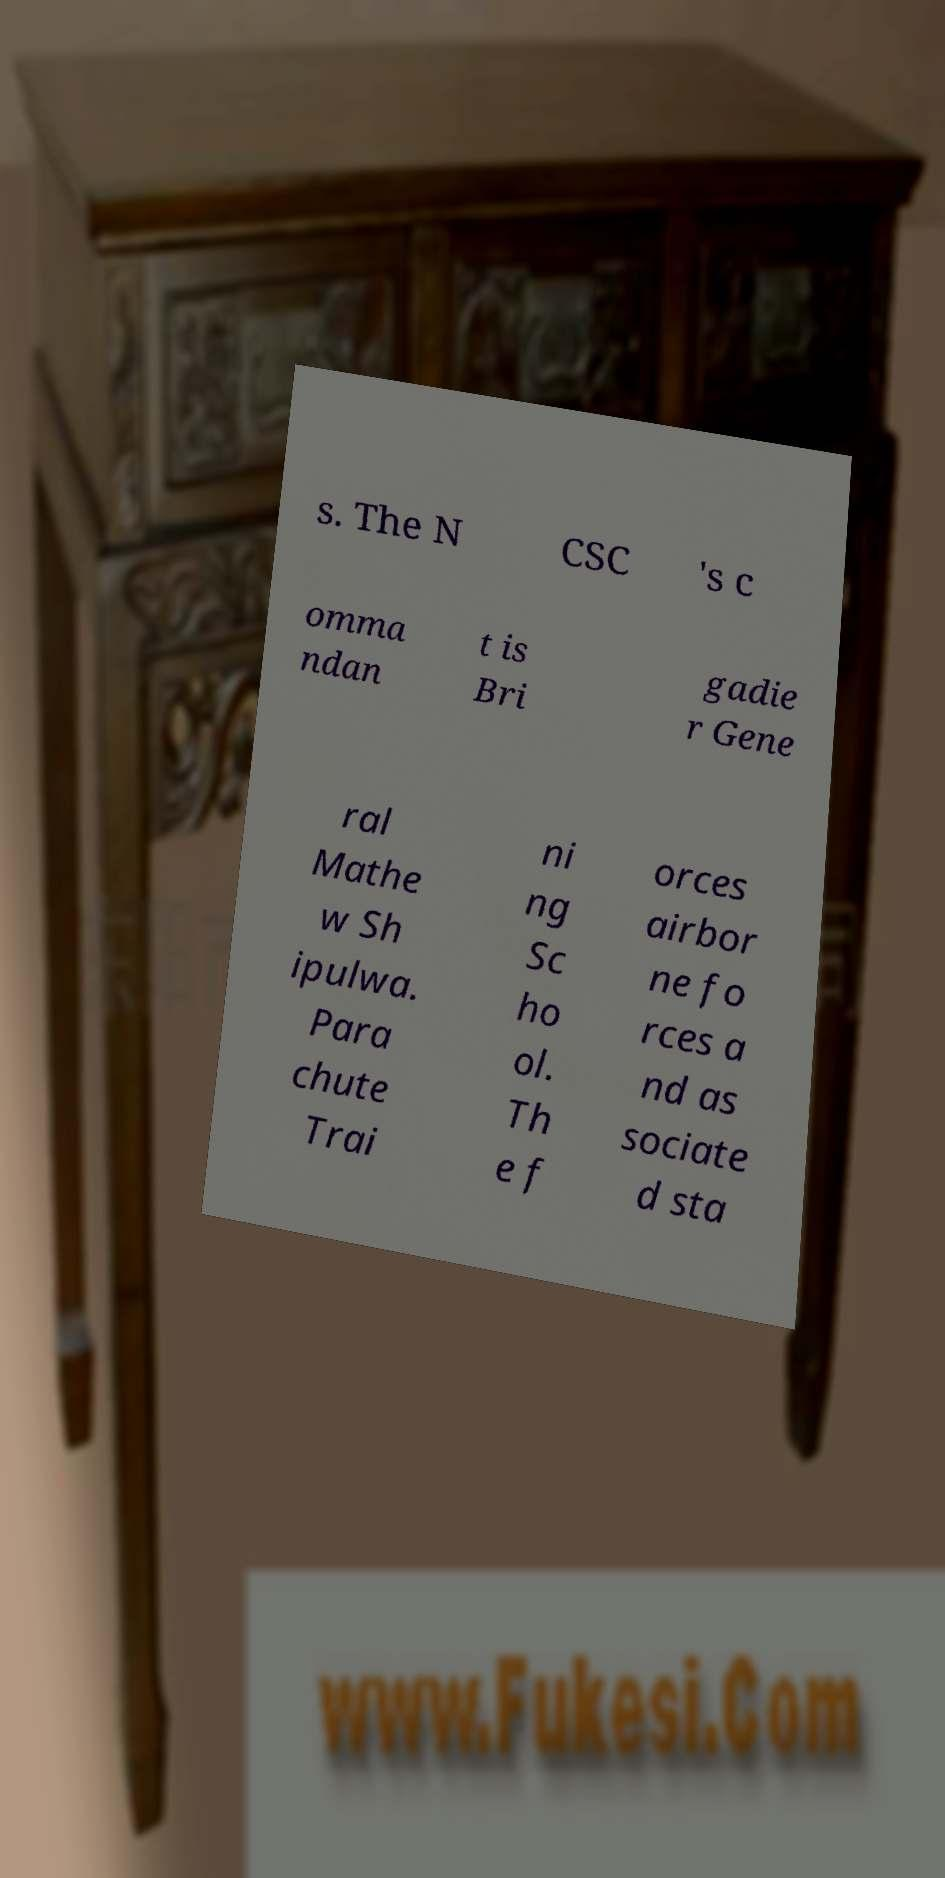There's text embedded in this image that I need extracted. Can you transcribe it verbatim? s. The N CSC 's c omma ndan t is Bri gadie r Gene ral Mathe w Sh ipulwa. Para chute Trai ni ng Sc ho ol. Th e f orces airbor ne fo rces a nd as sociate d sta 